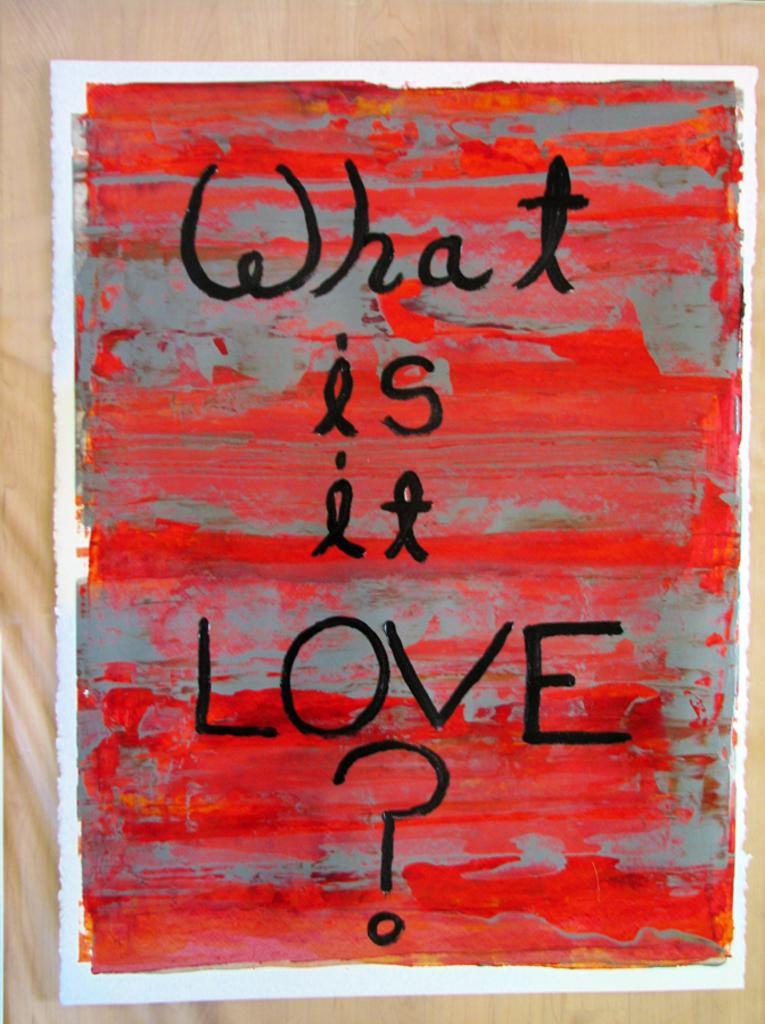<image>
Relay a brief, clear account of the picture shown. A hand painted sign using red and gray paint with written black words about Love on it. 